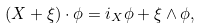<formula> <loc_0><loc_0><loc_500><loc_500>( X + \xi ) \cdot \phi = i _ { X } \phi + \xi \wedge \phi ,</formula> 